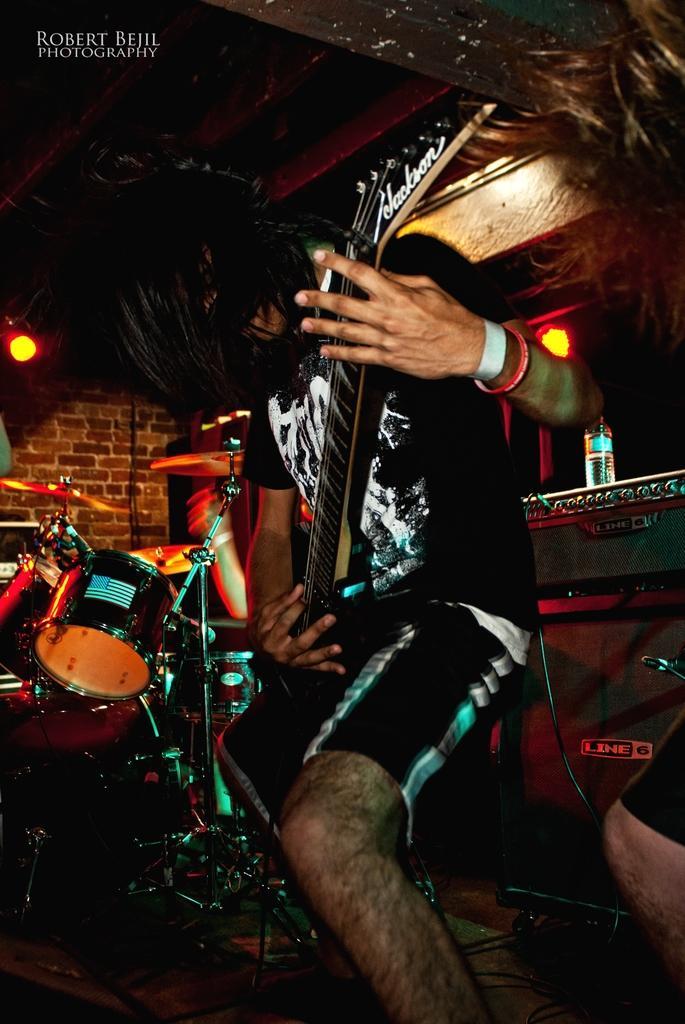In one or two sentences, can you explain what this image depicts? There is a man with black t-shirt is playing a guitar. Beside them there are drums. And we can see a brick wall and a light. 